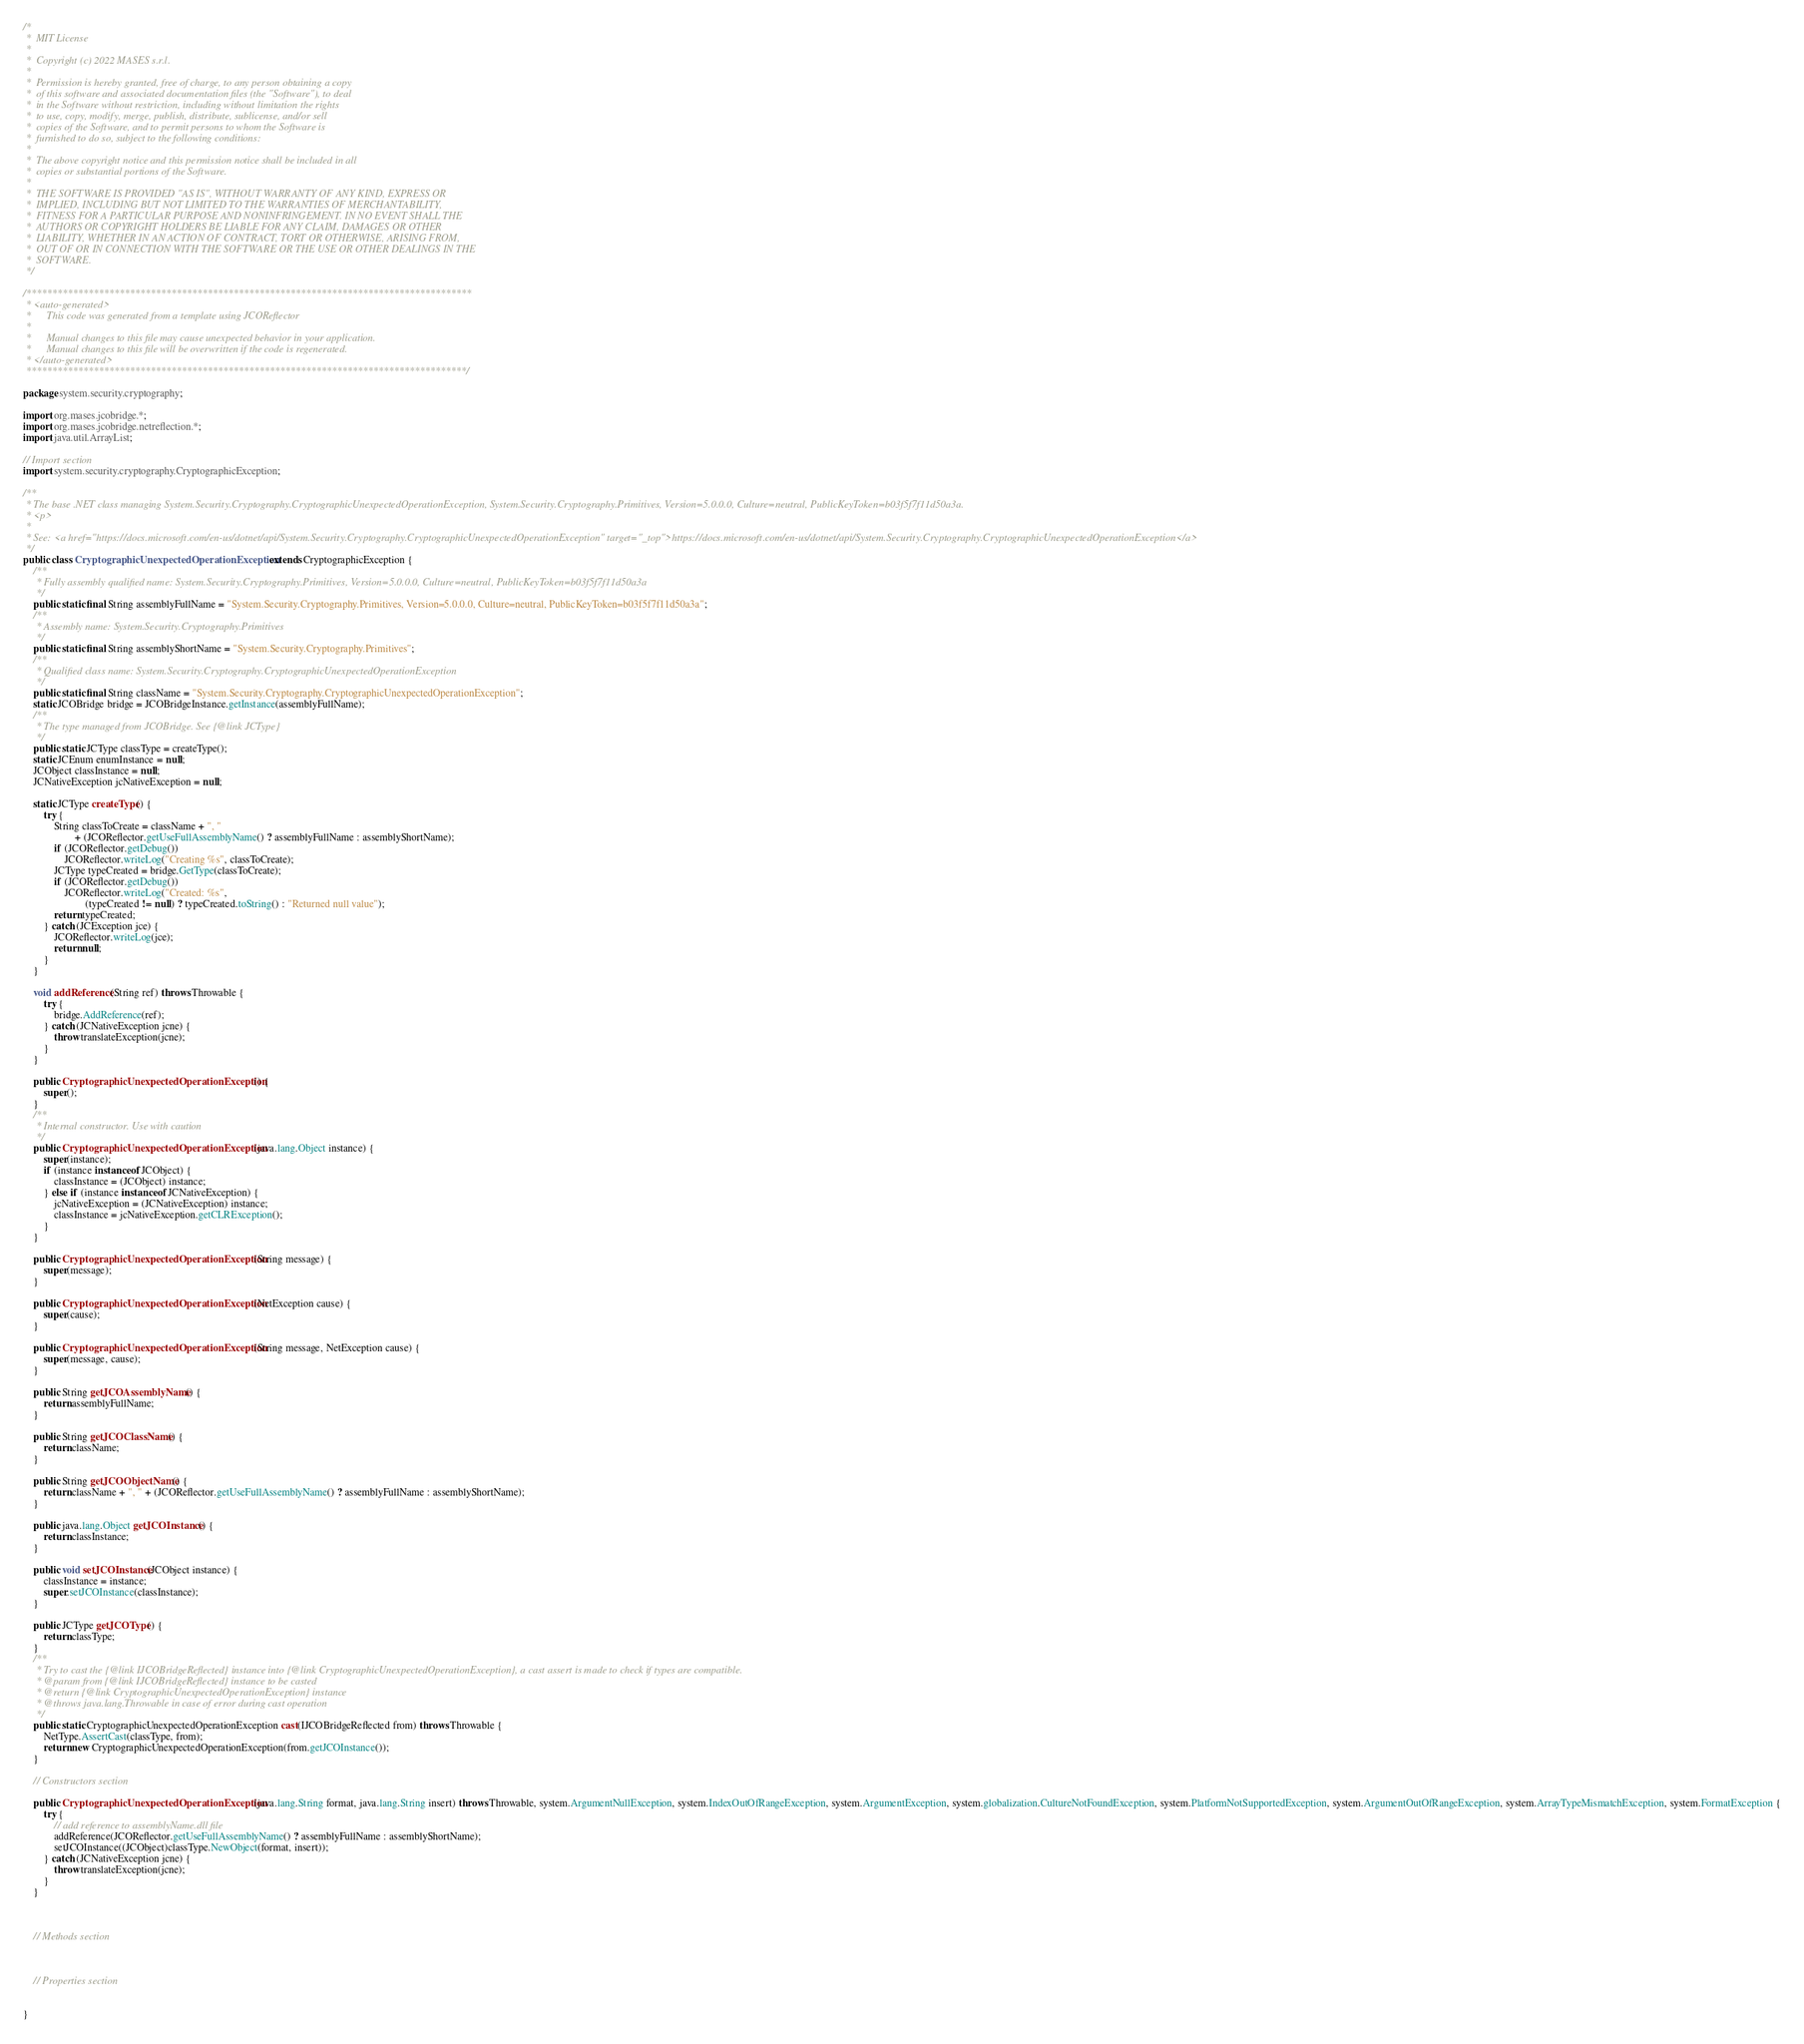Convert code to text. <code><loc_0><loc_0><loc_500><loc_500><_Java_>/*
 *  MIT License
 *
 *  Copyright (c) 2022 MASES s.r.l.
 *
 *  Permission is hereby granted, free of charge, to any person obtaining a copy
 *  of this software and associated documentation files (the "Software"), to deal
 *  in the Software without restriction, including without limitation the rights
 *  to use, copy, modify, merge, publish, distribute, sublicense, and/or sell
 *  copies of the Software, and to permit persons to whom the Software is
 *  furnished to do so, subject to the following conditions:
 *
 *  The above copyright notice and this permission notice shall be included in all
 *  copies or substantial portions of the Software.
 *
 *  THE SOFTWARE IS PROVIDED "AS IS", WITHOUT WARRANTY OF ANY KIND, EXPRESS OR
 *  IMPLIED, INCLUDING BUT NOT LIMITED TO THE WARRANTIES OF MERCHANTABILITY,
 *  FITNESS FOR A PARTICULAR PURPOSE AND NONINFRINGEMENT. IN NO EVENT SHALL THE
 *  AUTHORS OR COPYRIGHT HOLDERS BE LIABLE FOR ANY CLAIM, DAMAGES OR OTHER
 *  LIABILITY, WHETHER IN AN ACTION OF CONTRACT, TORT OR OTHERWISE, ARISING FROM,
 *  OUT OF OR IN CONNECTION WITH THE SOFTWARE OR THE USE OR OTHER DEALINGS IN THE
 *  SOFTWARE.
 */

/**************************************************************************************
 * <auto-generated>
 *      This code was generated from a template using JCOReflector
 * 
 *      Manual changes to this file may cause unexpected behavior in your application.
 *      Manual changes to this file will be overwritten if the code is regenerated.
 * </auto-generated>
 *************************************************************************************/

package system.security.cryptography;

import org.mases.jcobridge.*;
import org.mases.jcobridge.netreflection.*;
import java.util.ArrayList;

// Import section
import system.security.cryptography.CryptographicException;

/**
 * The base .NET class managing System.Security.Cryptography.CryptographicUnexpectedOperationException, System.Security.Cryptography.Primitives, Version=5.0.0.0, Culture=neutral, PublicKeyToken=b03f5f7f11d50a3a.
 * <p>
 * 
 * See: <a href="https://docs.microsoft.com/en-us/dotnet/api/System.Security.Cryptography.CryptographicUnexpectedOperationException" target="_top">https://docs.microsoft.com/en-us/dotnet/api/System.Security.Cryptography.CryptographicUnexpectedOperationException</a>
 */
public class CryptographicUnexpectedOperationException extends CryptographicException {
    /**
     * Fully assembly qualified name: System.Security.Cryptography.Primitives, Version=5.0.0.0, Culture=neutral, PublicKeyToken=b03f5f7f11d50a3a
     */
    public static final String assemblyFullName = "System.Security.Cryptography.Primitives, Version=5.0.0.0, Culture=neutral, PublicKeyToken=b03f5f7f11d50a3a";
    /**
     * Assembly name: System.Security.Cryptography.Primitives
     */
    public static final String assemblyShortName = "System.Security.Cryptography.Primitives";
    /**
     * Qualified class name: System.Security.Cryptography.CryptographicUnexpectedOperationException
     */
    public static final String className = "System.Security.Cryptography.CryptographicUnexpectedOperationException";
    static JCOBridge bridge = JCOBridgeInstance.getInstance(assemblyFullName);
    /**
     * The type managed from JCOBridge. See {@link JCType}
     */
    public static JCType classType = createType();
    static JCEnum enumInstance = null;
    JCObject classInstance = null;
    JCNativeException jcNativeException = null;

    static JCType createType() {
        try {
            String classToCreate = className + ", "
                    + (JCOReflector.getUseFullAssemblyName() ? assemblyFullName : assemblyShortName);
            if (JCOReflector.getDebug())
                JCOReflector.writeLog("Creating %s", classToCreate);
            JCType typeCreated = bridge.GetType(classToCreate);
            if (JCOReflector.getDebug())
                JCOReflector.writeLog("Created: %s",
                        (typeCreated != null) ? typeCreated.toString() : "Returned null value");
            return typeCreated;
        } catch (JCException jce) {
            JCOReflector.writeLog(jce);
            return null;
        }
    }

    void addReference(String ref) throws Throwable {
        try {
            bridge.AddReference(ref);
        } catch (JCNativeException jcne) {
            throw translateException(jcne);
        }
    }

    public CryptographicUnexpectedOperationException() {
        super();
    }
    /**
     * Internal constructor. Use with caution 
     */
    public CryptographicUnexpectedOperationException(java.lang.Object instance) {
        super(instance);
        if (instance instanceof JCObject) {
            classInstance = (JCObject) instance;
        } else if (instance instanceof JCNativeException) {
            jcNativeException = (JCNativeException) instance;
            classInstance = jcNativeException.getCLRException();
        }
    }

    public CryptographicUnexpectedOperationException(String message) {
        super(message);
    }

    public CryptographicUnexpectedOperationException(NetException cause) {
        super(cause);
    }

    public CryptographicUnexpectedOperationException(String message, NetException cause) {
        super(message, cause);
    }

    public String getJCOAssemblyName() {
        return assemblyFullName;
    }

    public String getJCOClassName() {
        return className;
    }

    public String getJCOObjectName() {
        return className + ", " + (JCOReflector.getUseFullAssemblyName() ? assemblyFullName : assemblyShortName);
    }

    public java.lang.Object getJCOInstance() {
        return classInstance;
    }

    public void setJCOInstance(JCObject instance) {
        classInstance = instance;
        super.setJCOInstance(classInstance);
    }

    public JCType getJCOType() {
        return classType;
    }
    /**
     * Try to cast the {@link IJCOBridgeReflected} instance into {@link CryptographicUnexpectedOperationException}, a cast assert is made to check if types are compatible.
     * @param from {@link IJCOBridgeReflected} instance to be casted
     * @return {@link CryptographicUnexpectedOperationException} instance
     * @throws java.lang.Throwable in case of error during cast operation
     */
    public static CryptographicUnexpectedOperationException cast(IJCOBridgeReflected from) throws Throwable {
        NetType.AssertCast(classType, from);
        return new CryptographicUnexpectedOperationException(from.getJCOInstance());
    }

    // Constructors section
    
    public CryptographicUnexpectedOperationException(java.lang.String format, java.lang.String insert) throws Throwable, system.ArgumentNullException, system.IndexOutOfRangeException, system.ArgumentException, system.globalization.CultureNotFoundException, system.PlatformNotSupportedException, system.ArgumentOutOfRangeException, system.ArrayTypeMismatchException, system.FormatException {
        try {
            // add reference to assemblyName.dll file
            addReference(JCOReflector.getUseFullAssemblyName() ? assemblyFullName : assemblyShortName);
            setJCOInstance((JCObject)classType.NewObject(format, insert));
        } catch (JCNativeException jcne) {
            throw translateException(jcne);
        }
    }


    
    // Methods section
    

    
    // Properties section
    

}</code> 